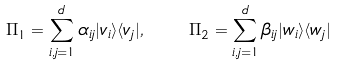<formula> <loc_0><loc_0><loc_500><loc_500>\Pi _ { 1 } = \sum _ { i , j = 1 } ^ { d } \alpha _ { i j } | v _ { i } \rangle \langle v _ { j } | , \quad \Pi _ { 2 } = \sum _ { i , j = 1 } ^ { d } \beta _ { i j } | w _ { i } \rangle \langle w _ { j } |</formula> 